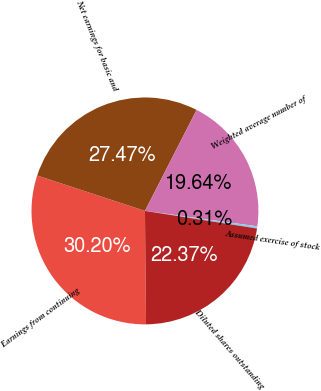Convert chart. <chart><loc_0><loc_0><loc_500><loc_500><pie_chart><fcel>Earnings from continuing<fcel>Net earnings for basic and<fcel>Weighted average number of<fcel>Assumed exercise of stock<fcel>Diluted shares outstanding<nl><fcel>30.2%<fcel>27.47%<fcel>19.64%<fcel>0.31%<fcel>22.37%<nl></chart> 